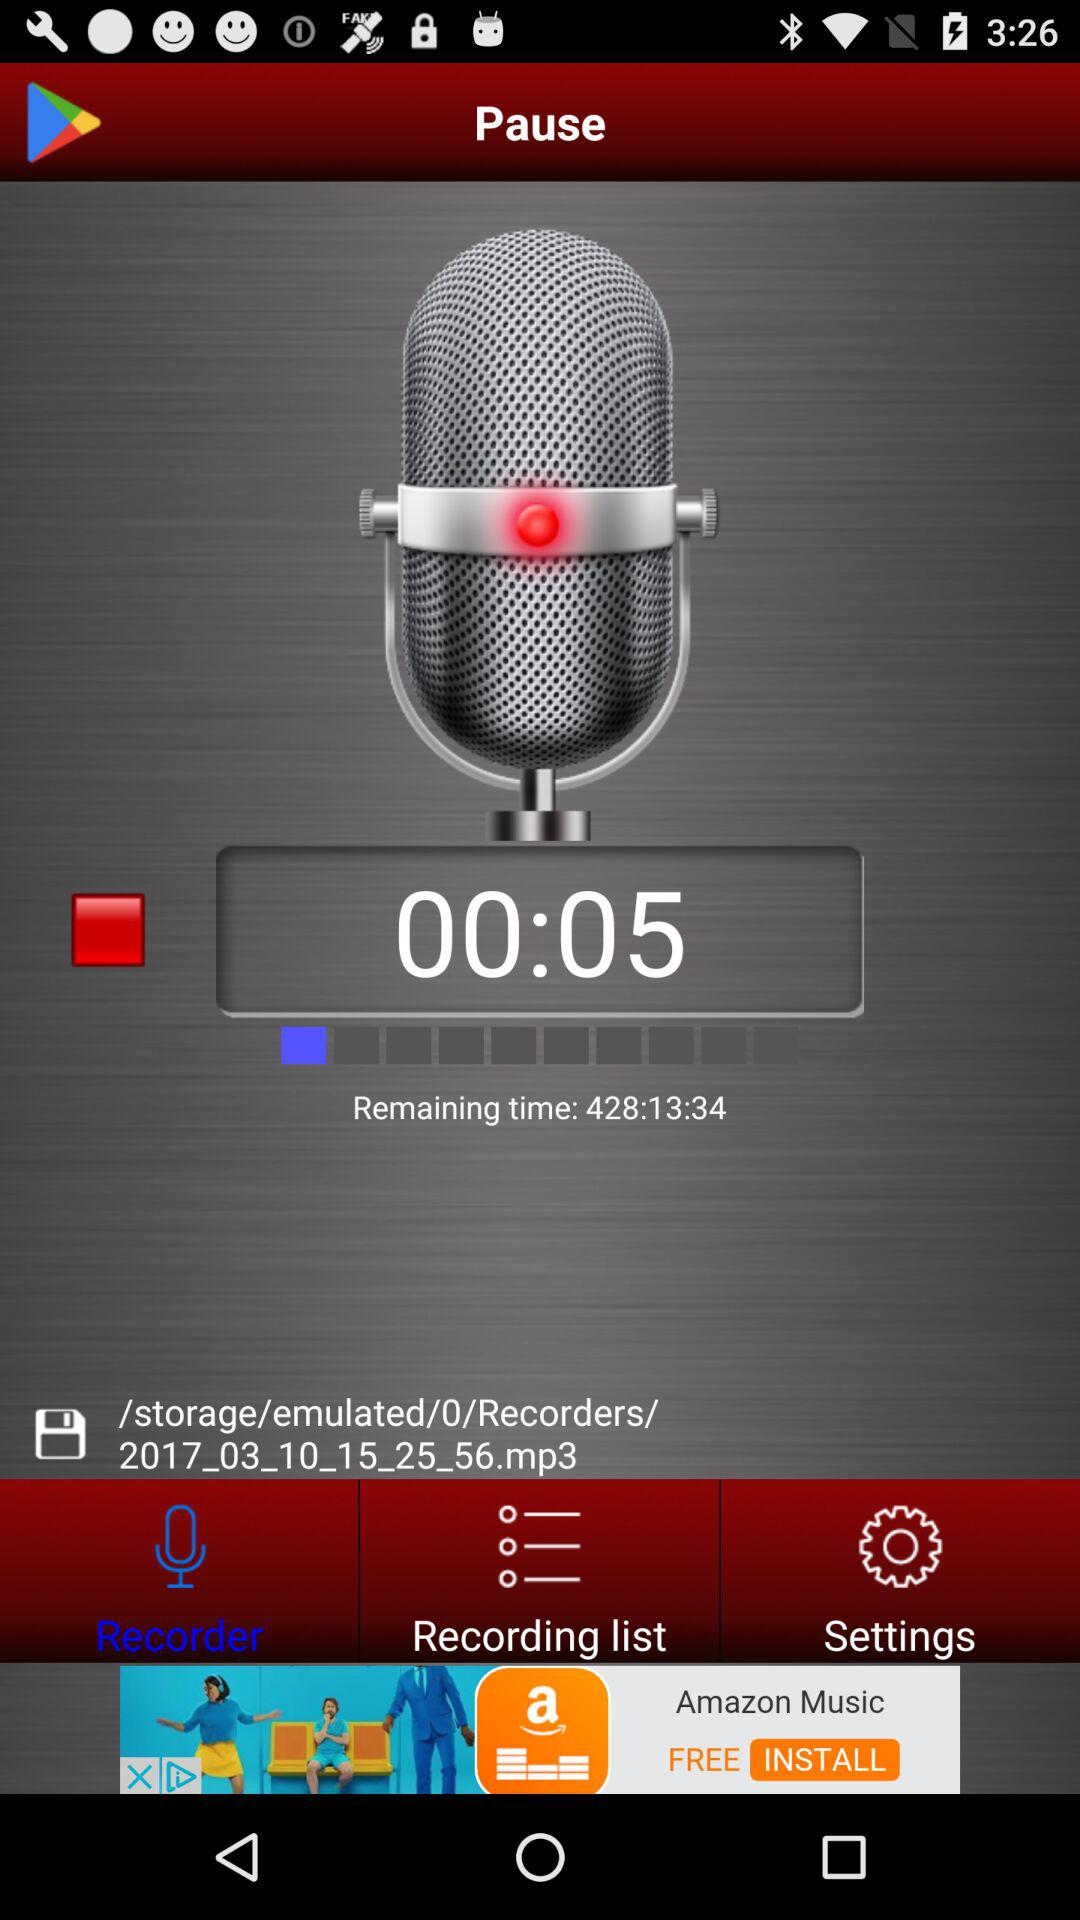What is the remaining time? The remaining time is 428:13:34. 